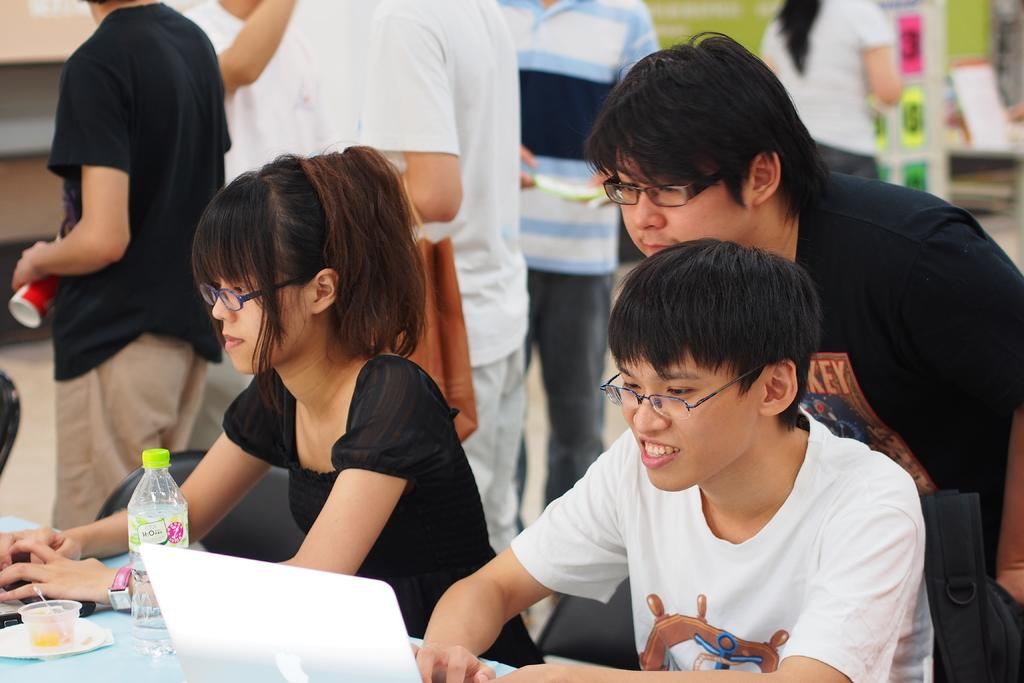How many people are sitting in the image? There are two persons sitting on chairs in the image. What is on the table in the image? There is a laptop, a bottle, and a cup on the table in the image. Can you describe the table in the image? The table is a surface where the laptop, bottle, and cup are placed. Are there any other people visible in the image? Yes, there are people visible in the background of the image. What type of attraction is the laptop drawing people to in the image? There is no attraction mentioned in the image, and the laptop is not drawing people to it. 